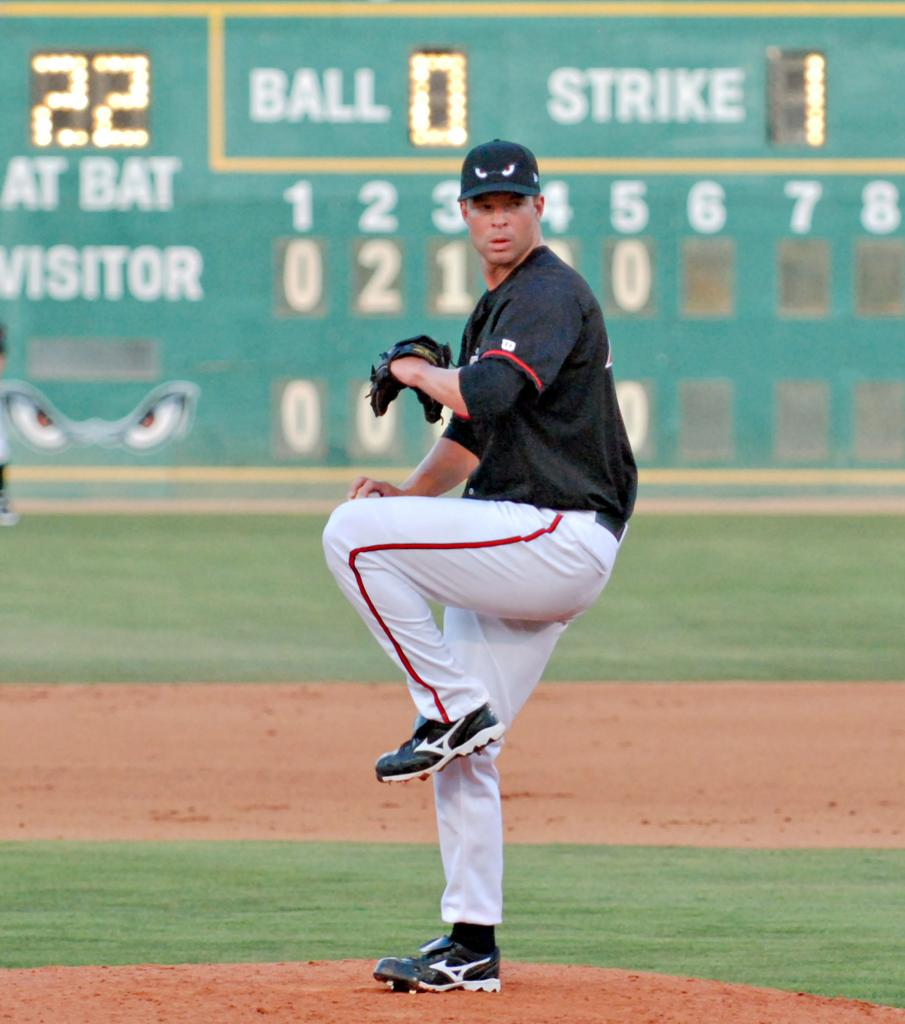<image>
Share a concise interpretation of the image provided. A baseball player ready to throw a pitch stand in front of a scoreboard that says 22 at bat 0 ball 1 strike 